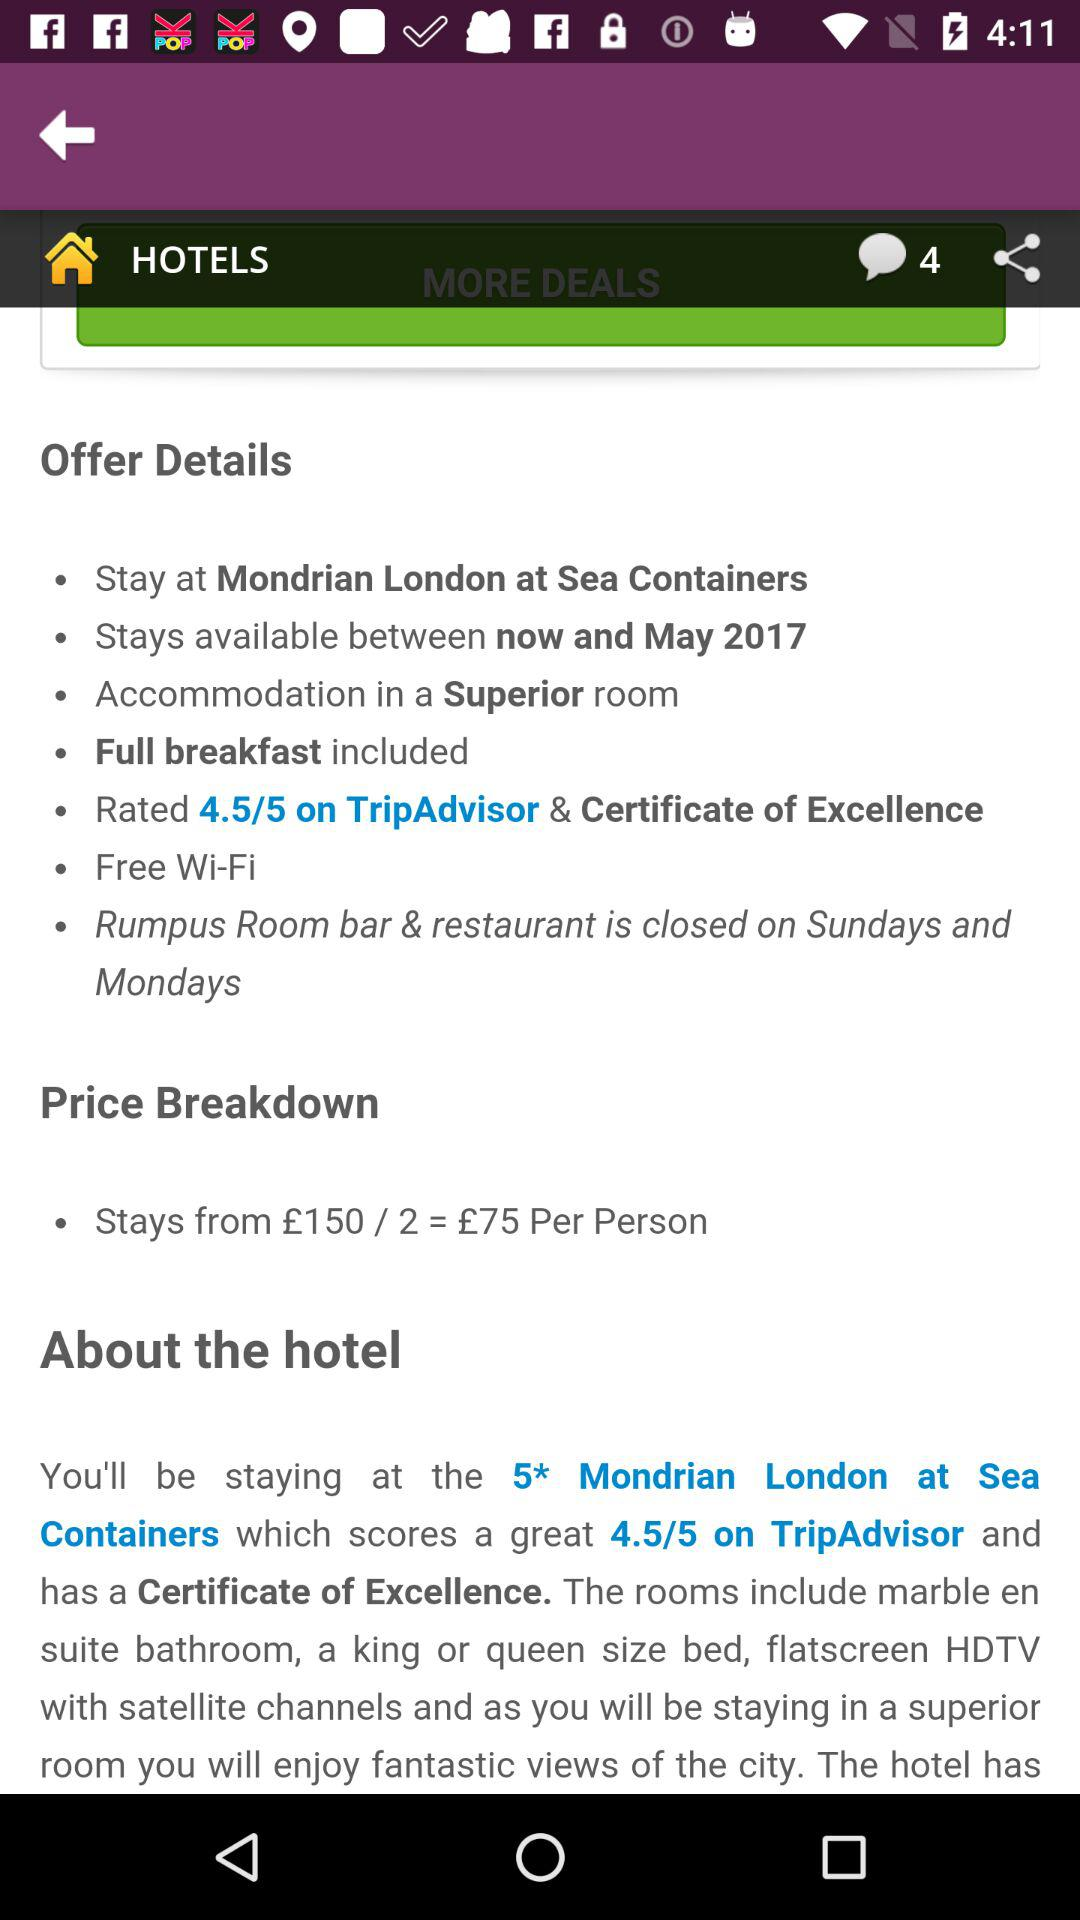What is the cost of Wi-Fi? The cost of Wi-Fi is free. 